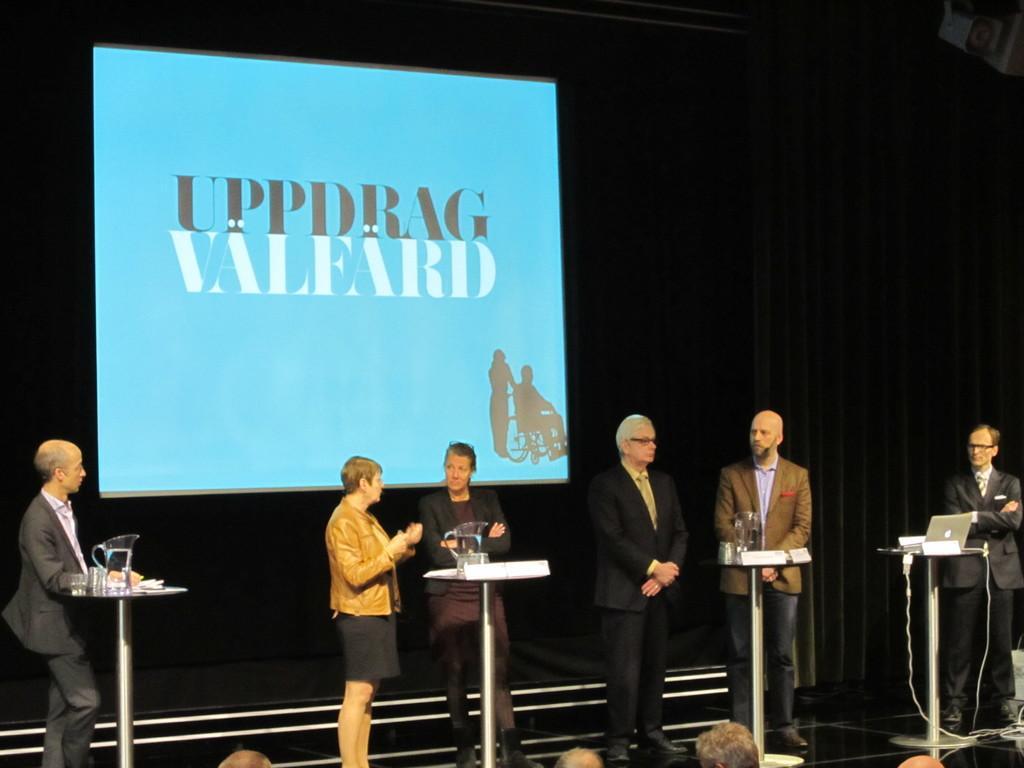Describe this image in one or two sentences. In the center of the picture there are tables, glasses, jars, laptop, cables, name plates and people standing. In the background there is a projector screen. At the bottom there are people's heads. In the background there are black curtains. 